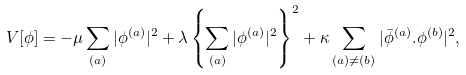<formula> <loc_0><loc_0><loc_500><loc_500>V [ \phi ] = - \mu \sum _ { ( a ) } | \phi ^ { ( a ) } | ^ { 2 } + \lambda \left \{ \sum _ { ( a ) } | \phi ^ { ( a ) } | ^ { 2 } \right \} ^ { 2 } + \kappa \sum _ { ( a ) \neq ( b ) } | \bar { \phi } ^ { ( a ) } . \phi ^ { ( b ) } | ^ { 2 } ,</formula> 